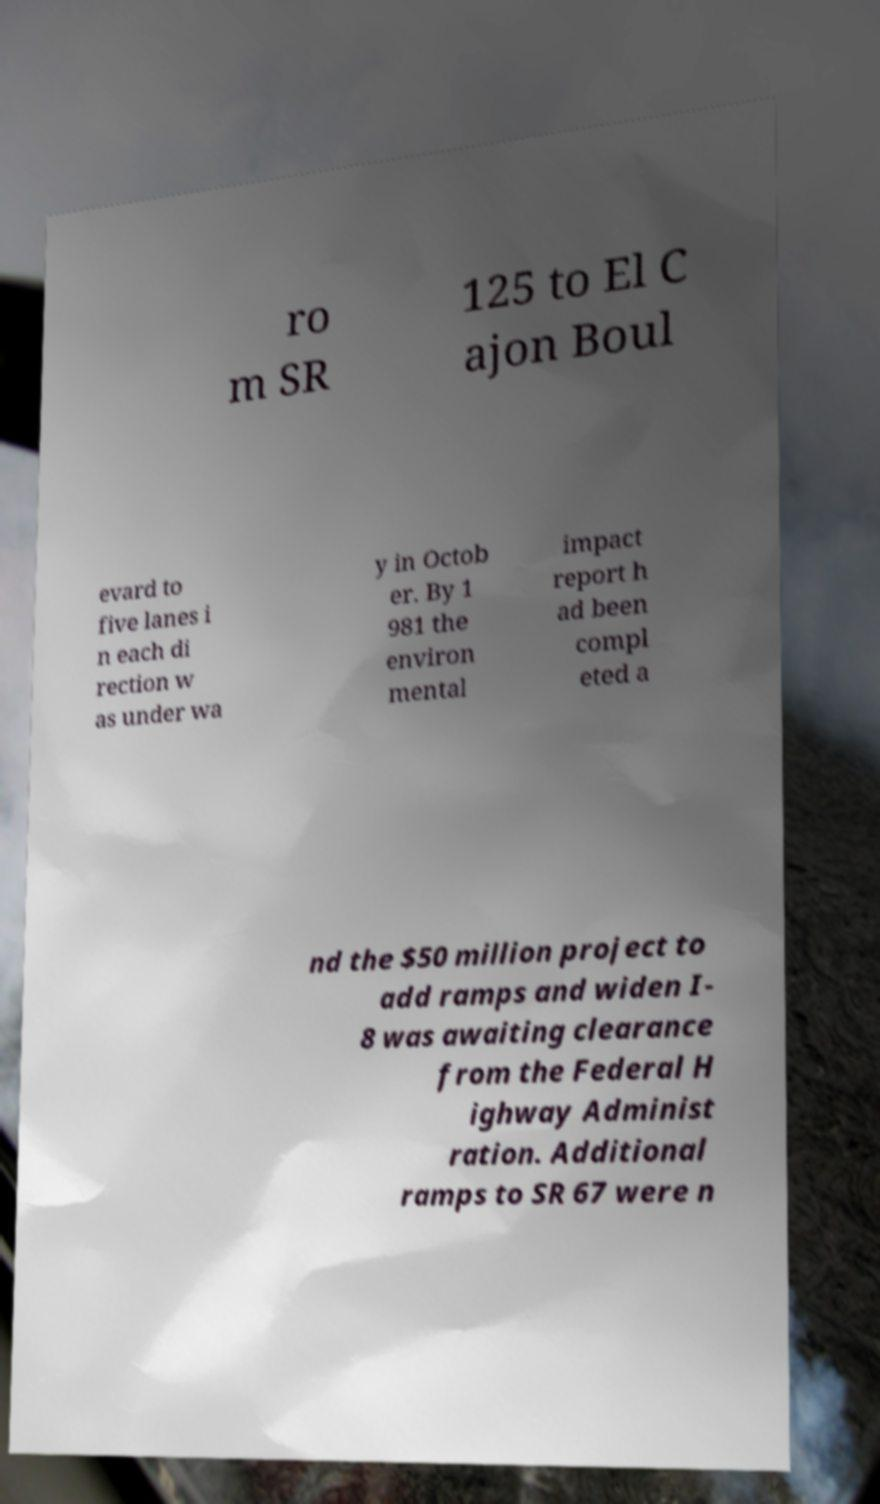Please identify and transcribe the text found in this image. ro m SR 125 to El C ajon Boul evard to five lanes i n each di rection w as under wa y in Octob er. By 1 981 the environ mental impact report h ad been compl eted a nd the $50 million project to add ramps and widen I- 8 was awaiting clearance from the Federal H ighway Administ ration. Additional ramps to SR 67 were n 